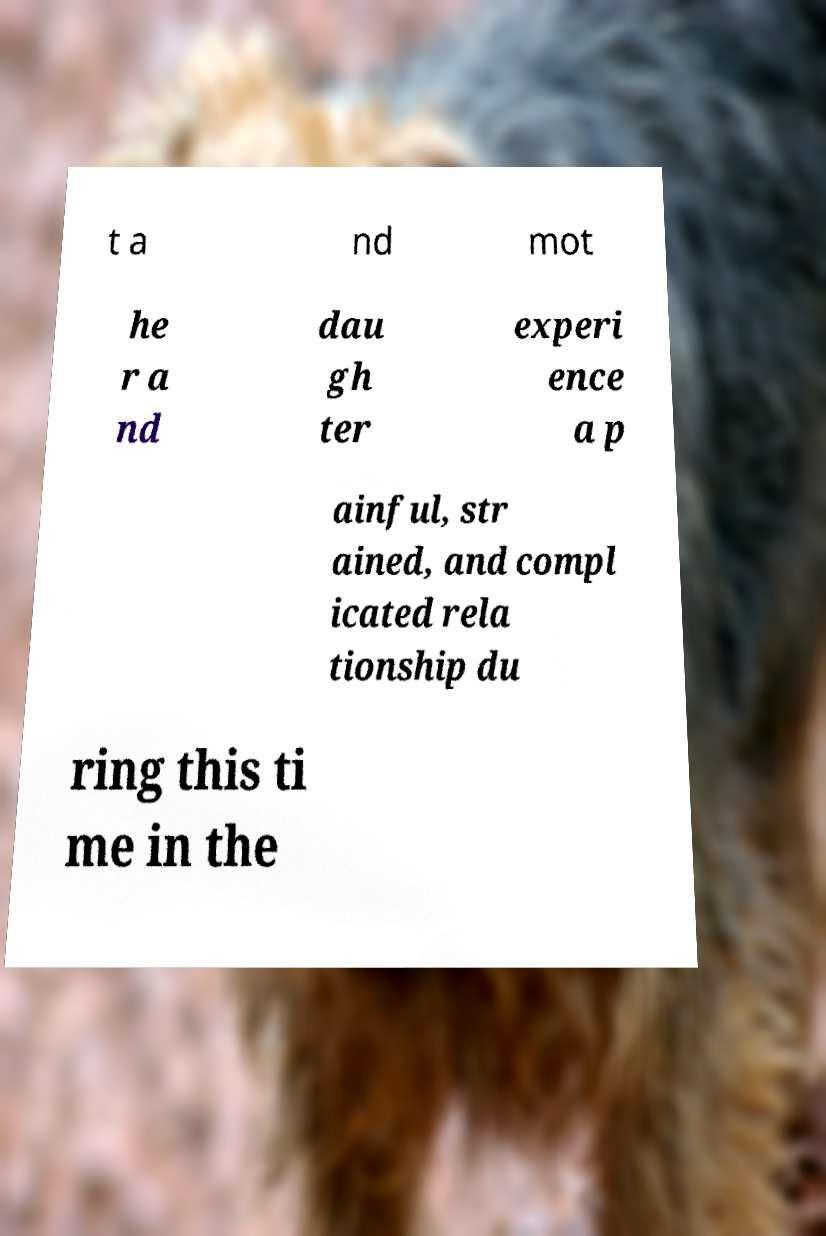I need the written content from this picture converted into text. Can you do that? t a nd mot he r a nd dau gh ter experi ence a p ainful, str ained, and compl icated rela tionship du ring this ti me in the 